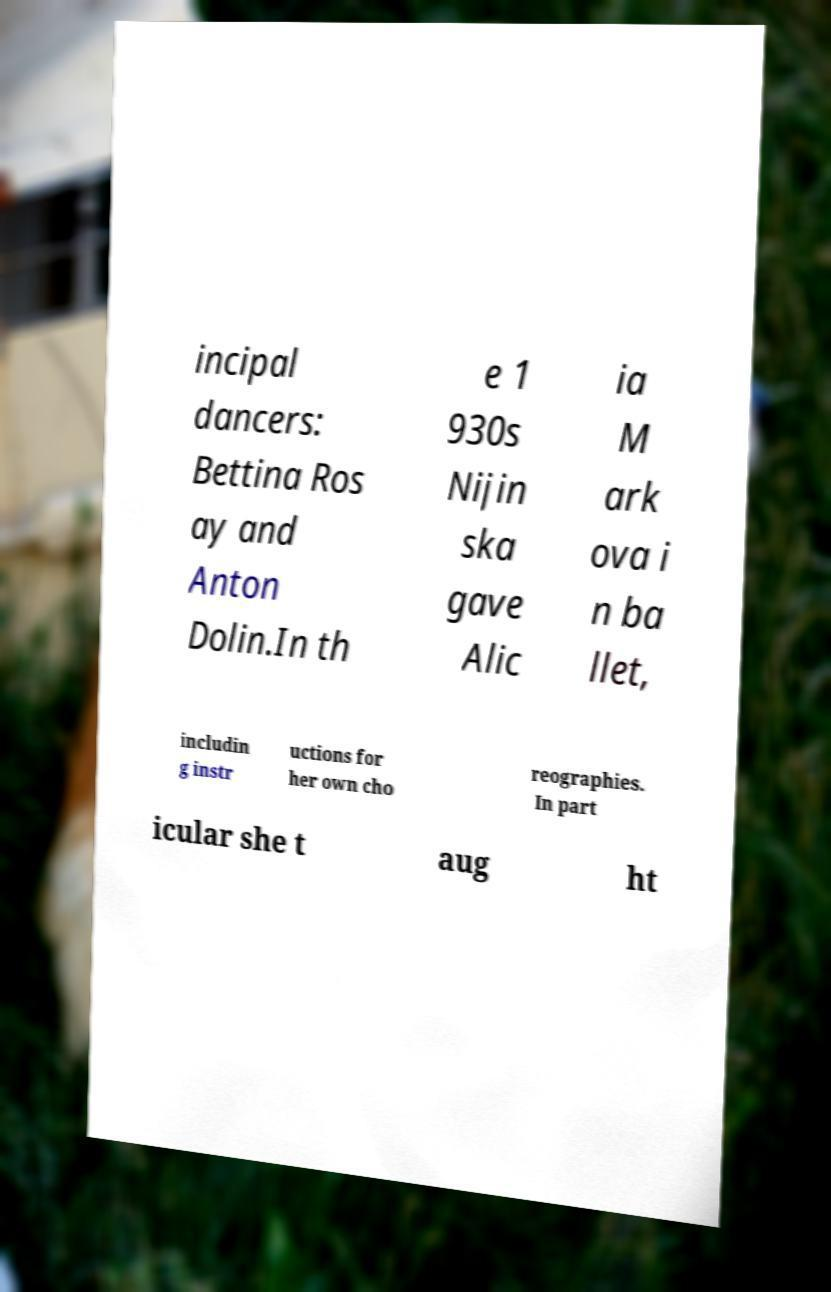I need the written content from this picture converted into text. Can you do that? incipal dancers: Bettina Ros ay and Anton Dolin.In th e 1 930s Nijin ska gave Alic ia M ark ova i n ba llet, includin g instr uctions for her own cho reographies. In part icular she t aug ht 